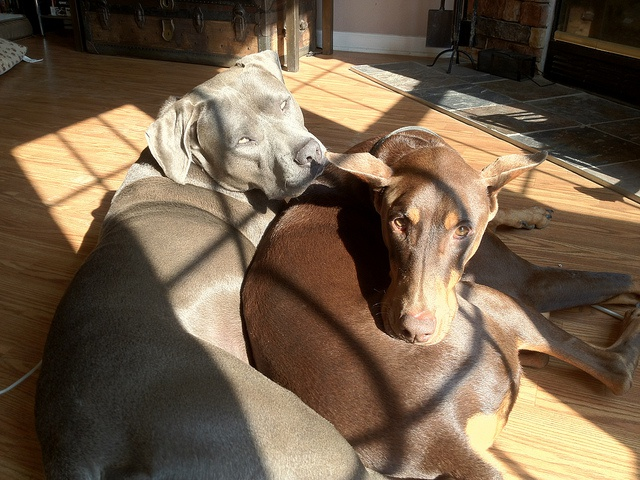Describe the objects in this image and their specific colors. I can see dog in black, maroon, and gray tones and dog in black, gray, beige, and tan tones in this image. 